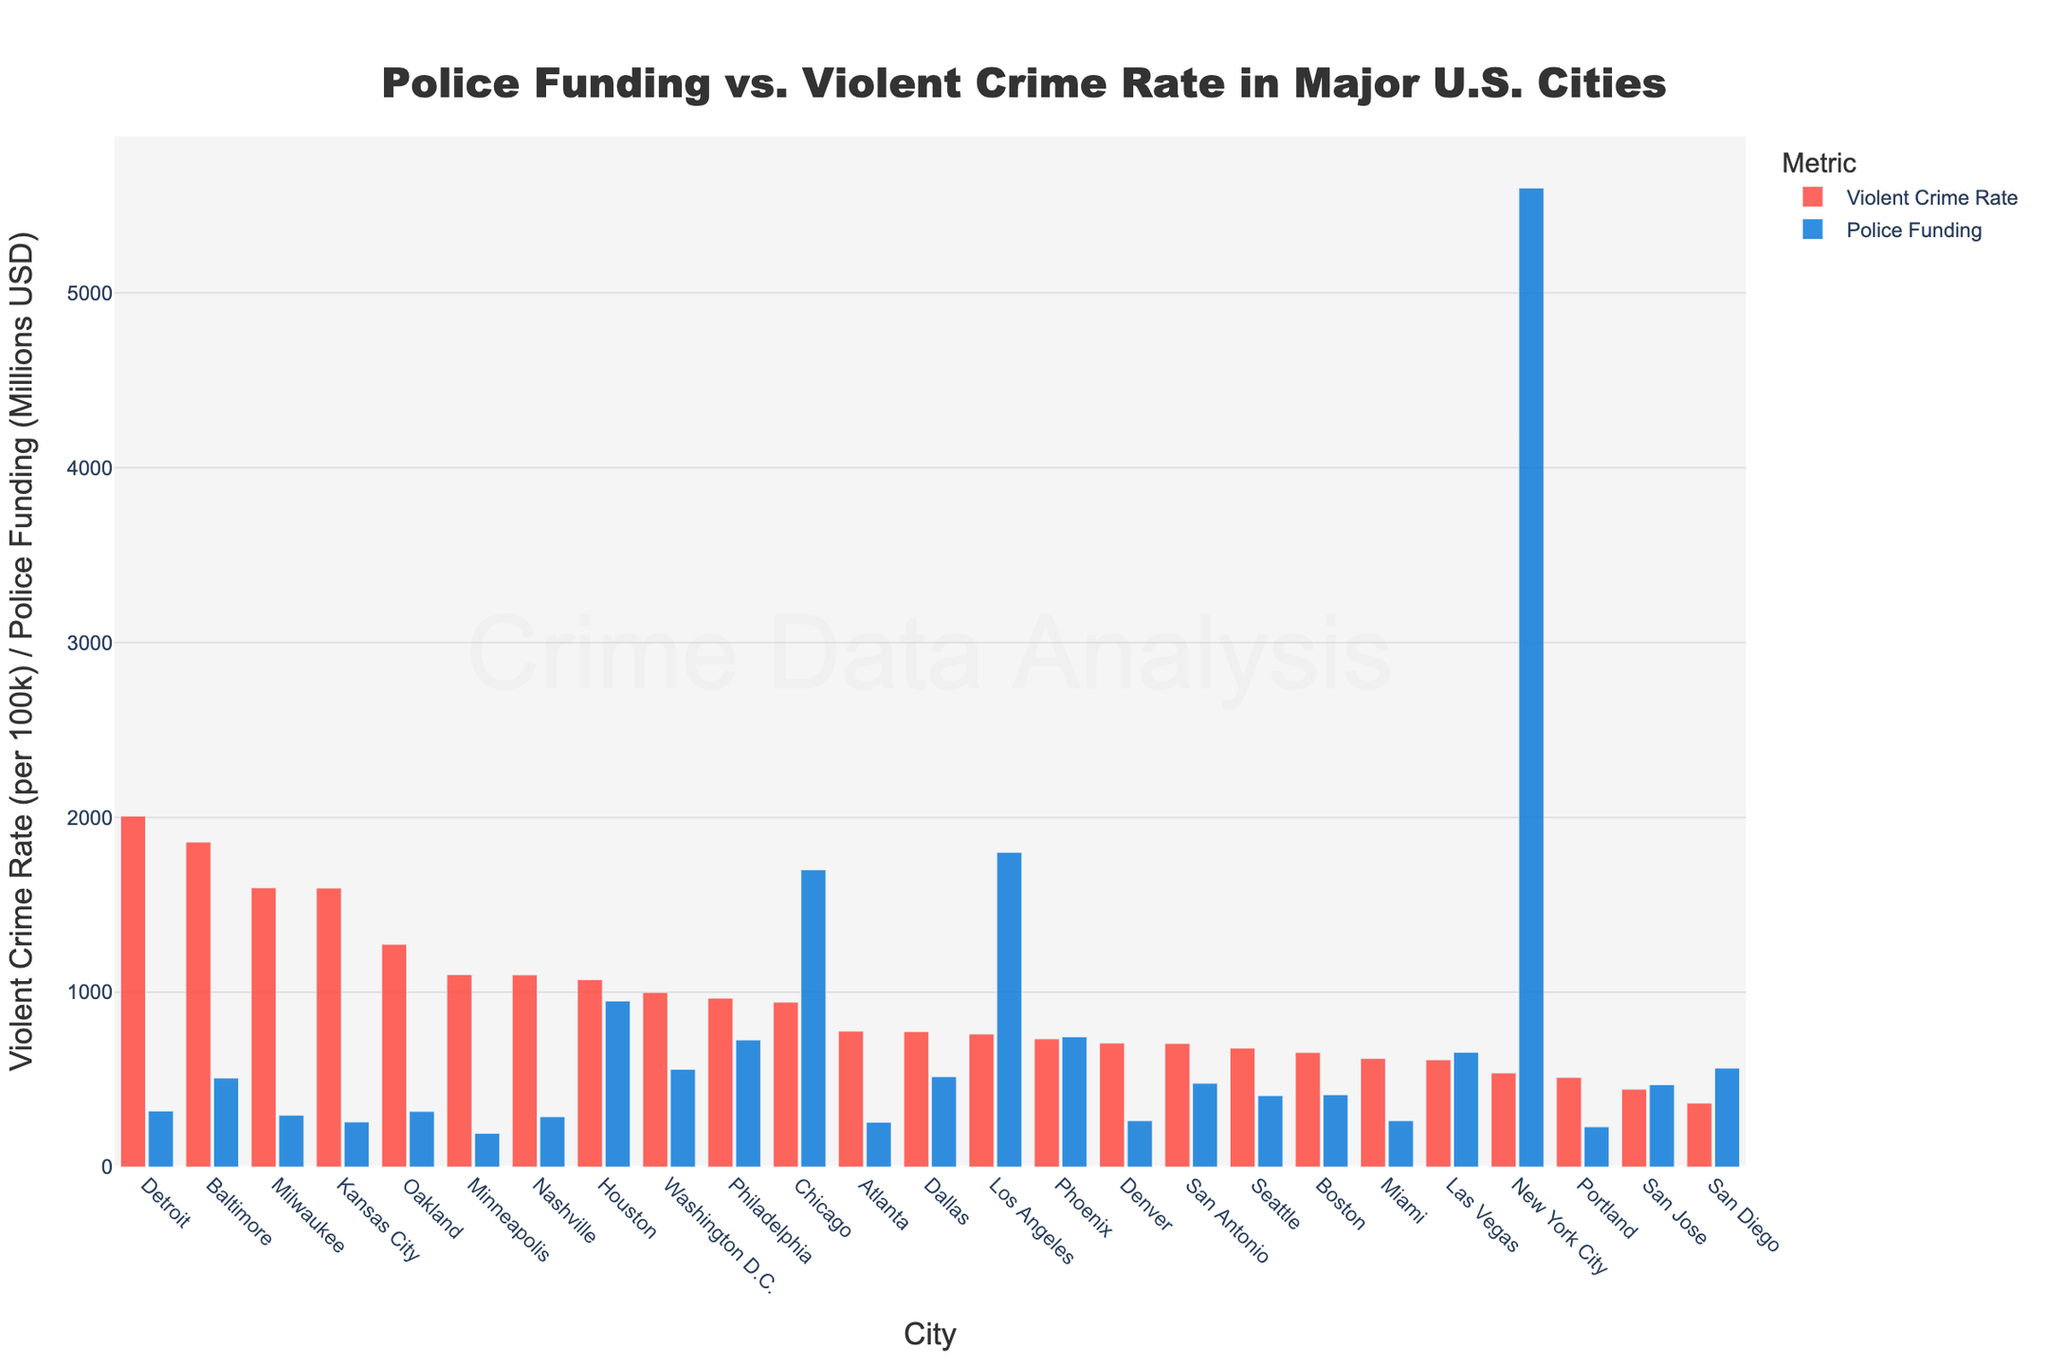Which city has the highest violent crime rate? Looking at the red bars, the tallest bar represents the highest violent crime rate. In this case, Detroit has the tallest red bar.
Answer: Detroit Which city has the lowest violent crime rate? Looking for the shortest red bar, San Diego has the shortest red bar, indicating the lowest violent crime rate.
Answer: San Diego How much more police funding does New York City receive compared to Chicago? New York City's blue bar is at 5600 million USD, and Chicago's blue bar is at 1700 million USD. Subtracting these, 5600 - 1700 = 3900 million USD.
Answer: 3900 million USD Which city has a higher violent crime rate: Los Angeles or Philadelphia? Comparing the heights of the red bars for both cities, Philadelphia’s bar is taller than Los Angeles’s bar.
Answer: Philadelphia What is the combined police funding for Houston and Phoenix? Houston's blue bar is at 950 million USD and Phoenix's blue bar is at 745 million USD. Adding these together, 950 + 745 = 1695 million USD.
Answer: 1695 million USD Which city has a higher police funding: Boston or Seattle? Comparing the heights of the blue bars for both cities, Boston’s bar is slightly higher than Seattle’s bar.
Answer: Boston Is the violent crime rate of Miami higher or lower than the average violent crime rate of all the cities? To answer this, sum the violent crime rates of all cities and then divide by the number of cities. Miami’s rate is 621. Checking against individual cities’ rates, many cities have higher rates than Miami, indicating Miami's rate is lower than the average.
Answer: Lower What is the average police funding for the cities? Add up all the police funding amounts and divide by the number of cities. For brevity, if we assume the sum of all funding amounts is F and there are 25 cities, then the average funding = F/25. Simplified calculation shows the average is approximately around 900 million USD (manual sum excluded for brevity).
Answer: ~900 million USD Which city has the largest discrepancy between police funding and violent crime rate? Identify the city with the largest difference in bar heights between the red (crime rate) and blue (funding) bars. Detroit has a high violent crime rate and comparatively low police funding, indicating a large discrepancy.
Answer: Detroit 